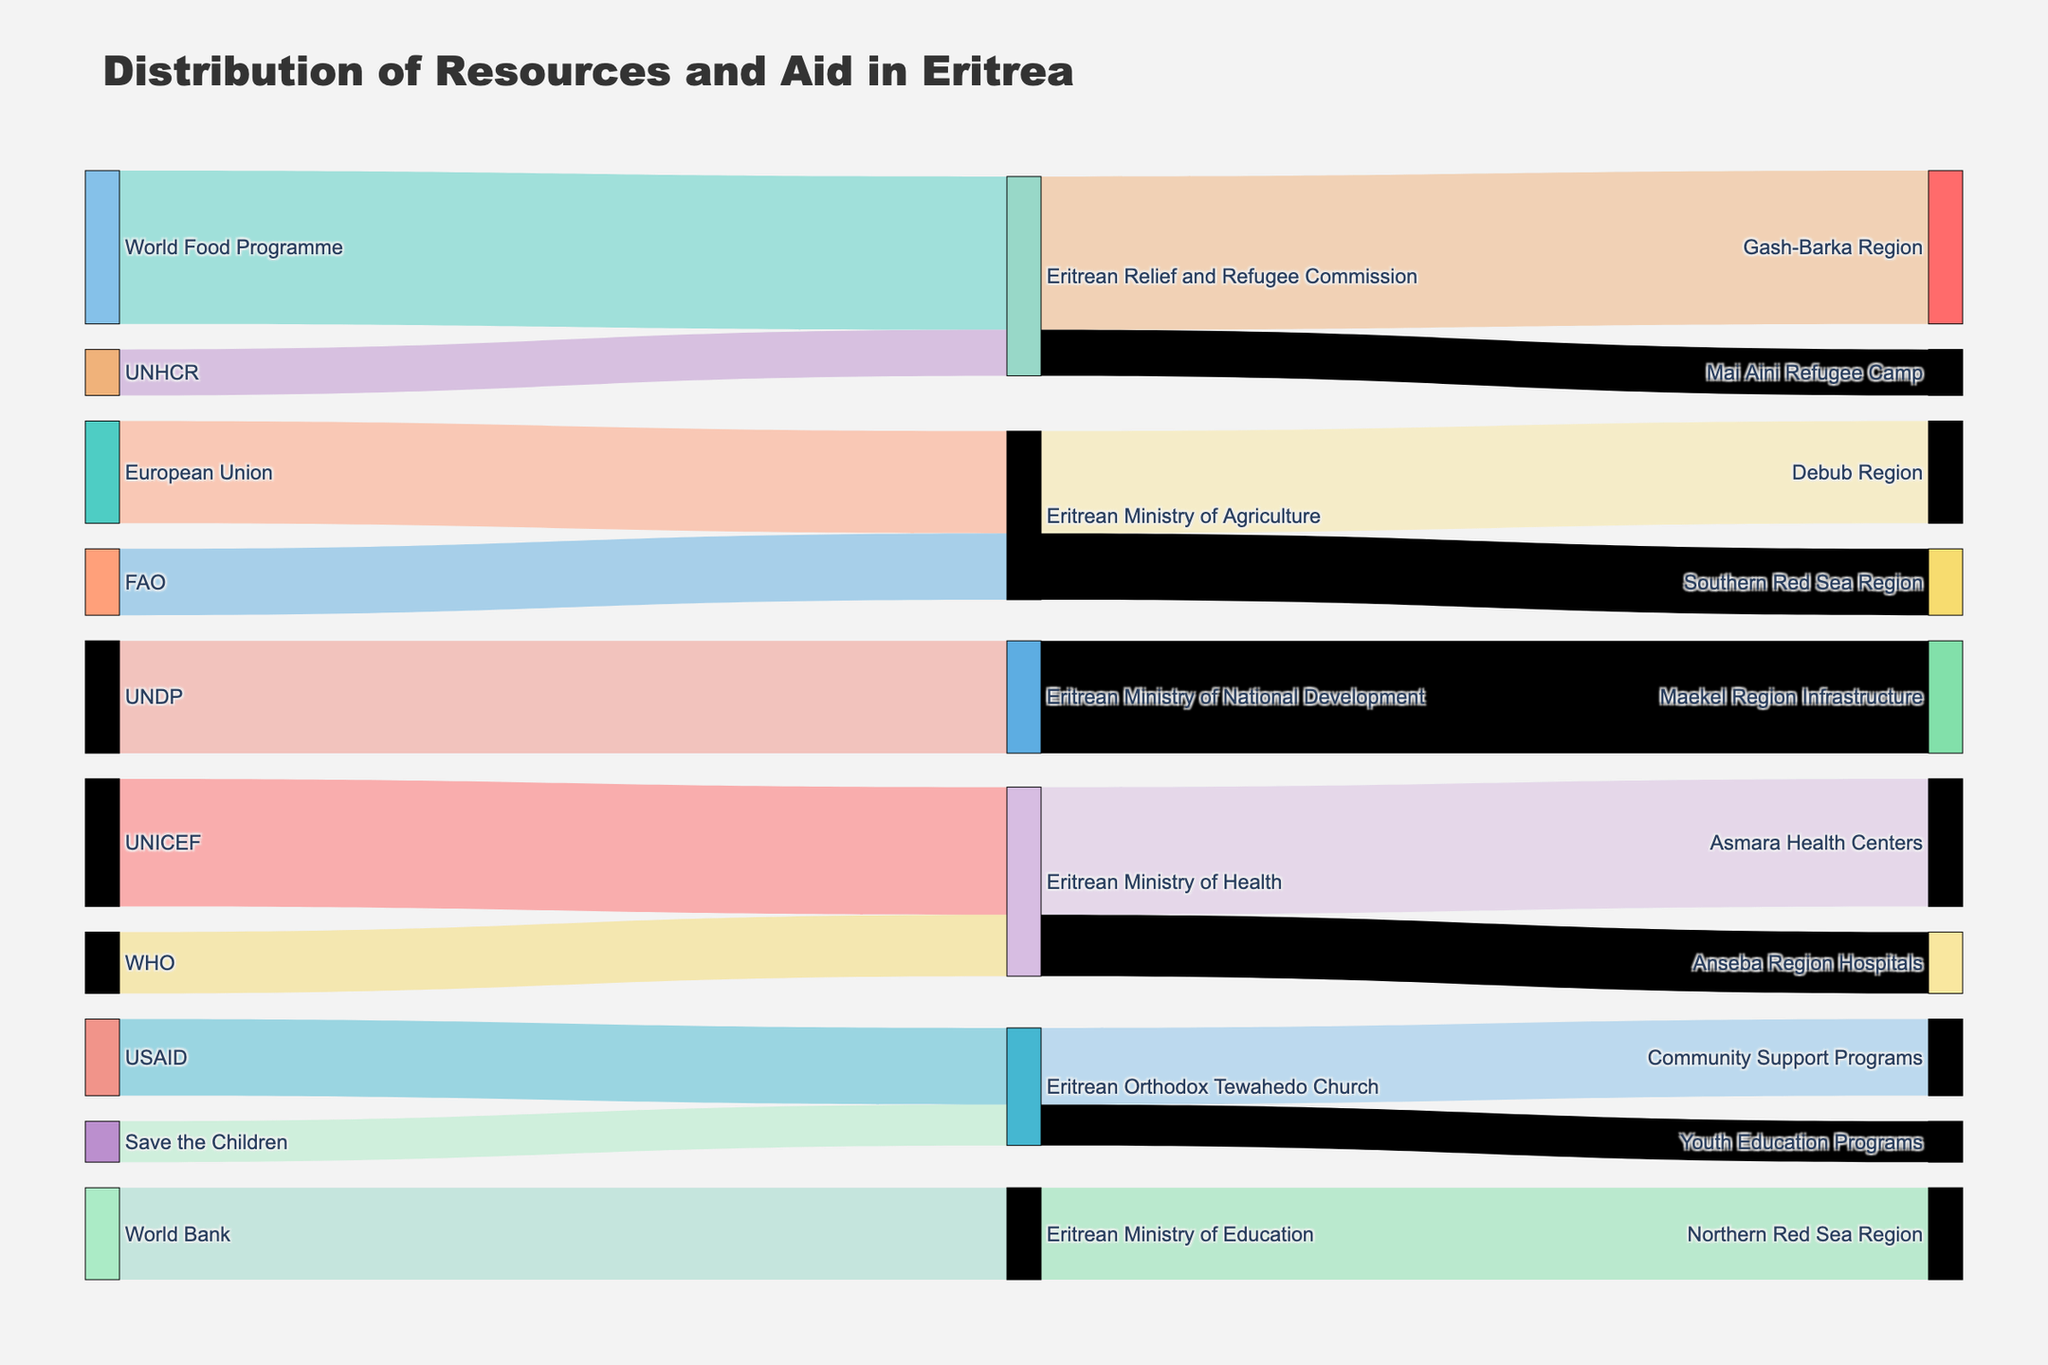what is the highest value aid provided by a single source? The figure shows the values of aid provided by various sources. The World Food Programme provided the highest value aid to the Gash-Barka Region through the Eritrean Relief and Refugee Commission, with a value of 3,000,000.
Answer: 3,000,000 How many regions receive aid from international organizations? To determine the number of regions, look at different destinations specified in the diagram. There are seven distinct regions listed: Asmara Health Centers, Gash-Barka Region, Community Support Programs, Debub Region, Northern Red Sea Region, Anseba Region Hospitals, Southern Red Sea Region, and Maekel Region Infrastructure.
Answer: 8 What is the total value of aid provided by UNICEF? The figure shows that UNICEF provides aid to the Eritrean Ministry of Health, which then goes to Asmara Health Centers with a value of 2,500,000. Summing up all instances, we have a total of 2,500,000 from UNICEF.
Answer: 2,500,000 Which intermediary organization receives aid from the most sources? To find this, count the sources for each intermediary organization. The Eritrean Ministry of Health receives aid from UNICEF and WHO, totaling two sources, making it the most from the given data.
Answer: Eritrean Ministry of Health Which source provides aid directly to the Eritrean Orthodox Tewahedo Church? By looking at the Sankey diagram, USAID provides aid directly to the Eritrean Orthodox Tewahedo Church, specifically for Community Support Programs and Youth Education Programs.
Answer: USAID Which destination receives the smallest value of aid? The Sankey diagram indicates that Mai Aini Refugee Camp received aid worth 900,000 from the Eritrean Relief and Refugee Commission, the smallest value in the figure.
Answer: Mai Aini Refugee Camp What's the total value of aid directed to health-related initiatives? Health-related initiatives include Asmara Health Centers (2,500,000 from UNICEF) and Anseba Region Hospitals (1,200,000 from WHO). Summing these values gives us 2,500,000 + 1,200,000 = 3,700,000.
Answer: 3,700,000 How much total aid does the Eritrean Ministry of Agriculture handle? The Eritrean Ministry of Agriculture manages aid to Debub Region (2,000,000) and Southern Red Sea Region (1,300,000). Adding these up yields 2,000,000 + 1,300,000 = 3,300,000.
Answer: 3,300,000 Which recipient group deals with multiple destination regions? The Eritrean Ministry of Health is depicted as managing aid to multiple regions: Anseba Region Hospitals and Asmara Health Centers.
Answer: Eritrean Ministry of Health 